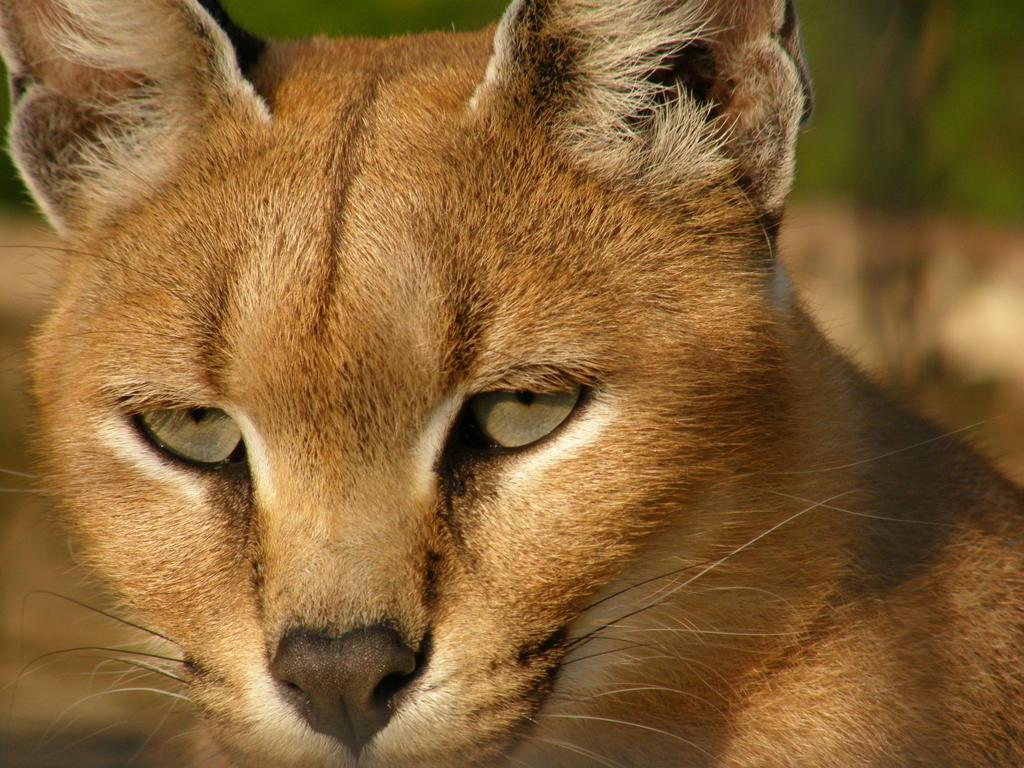What type of animal is in the image? There is a wild cat in the image. What is the name of the wild cat? The wild cat is named caracal. Can you describe the background of the image? The background of the image appears blurry. What type of bait is the caracal using to catch its prey in the image? There is no prey or bait present in the image; it simply features a caracal. How does the caracal react to the sound of an engine in the image? There is no sound of an engine or any reaction by the caracal in the image. 